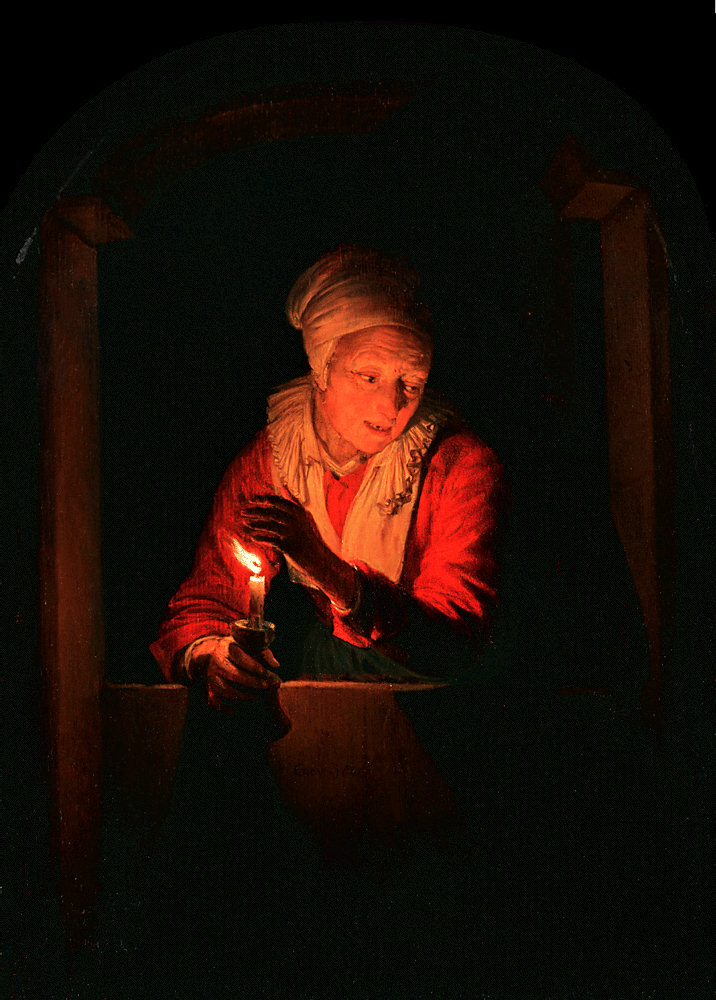Can you tell a very short story involving this scene? In a tranquil village, Elda lit her nightly candle, hoping to guide her long-lost granddaughter back home. One stormy night, the candle's glow pierced the darkness, and when Elda looked up, she saw a familiar silhouette at her door, reunited at last. 